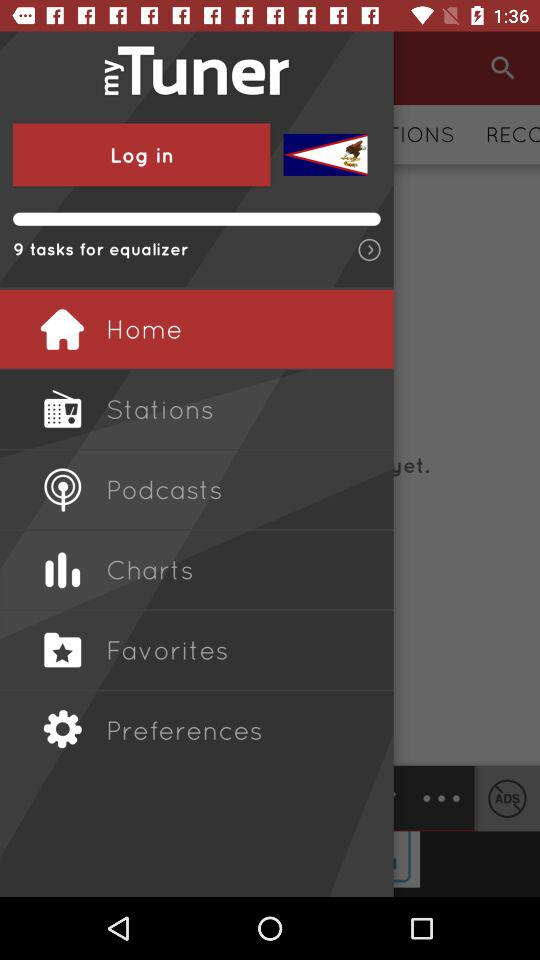What is the name of the application? The name of the application is "myTuner". 